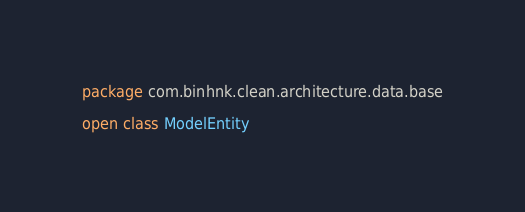Convert code to text. <code><loc_0><loc_0><loc_500><loc_500><_Kotlin_>package com.binhnk.clean.architecture.data.base

open class ModelEntity</code> 